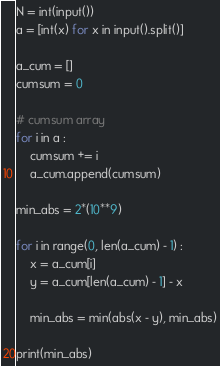Convert code to text. <code><loc_0><loc_0><loc_500><loc_500><_Python_>N = int(input())
a = [int(x) for x in input().split()]

a_cum = []
cumsum = 0

# cumsum array
for i in a :
    cumsum += i
    a_cum.append(cumsum)

min_abs = 2*(10**9)

for i in range(0, len(a_cum) - 1) :
    x = a_cum[i]
    y = a_cum[len(a_cum) - 1] - x
    
    min_abs = min(abs(x - y), min_abs)
    
print(min_abs)</code> 